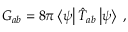Convert formula to latex. <formula><loc_0><loc_0><loc_500><loc_500>G _ { a b } = 8 \pi \left < \psi \right | \hat { T } _ { a b } \left | \psi \right > \, ,</formula> 